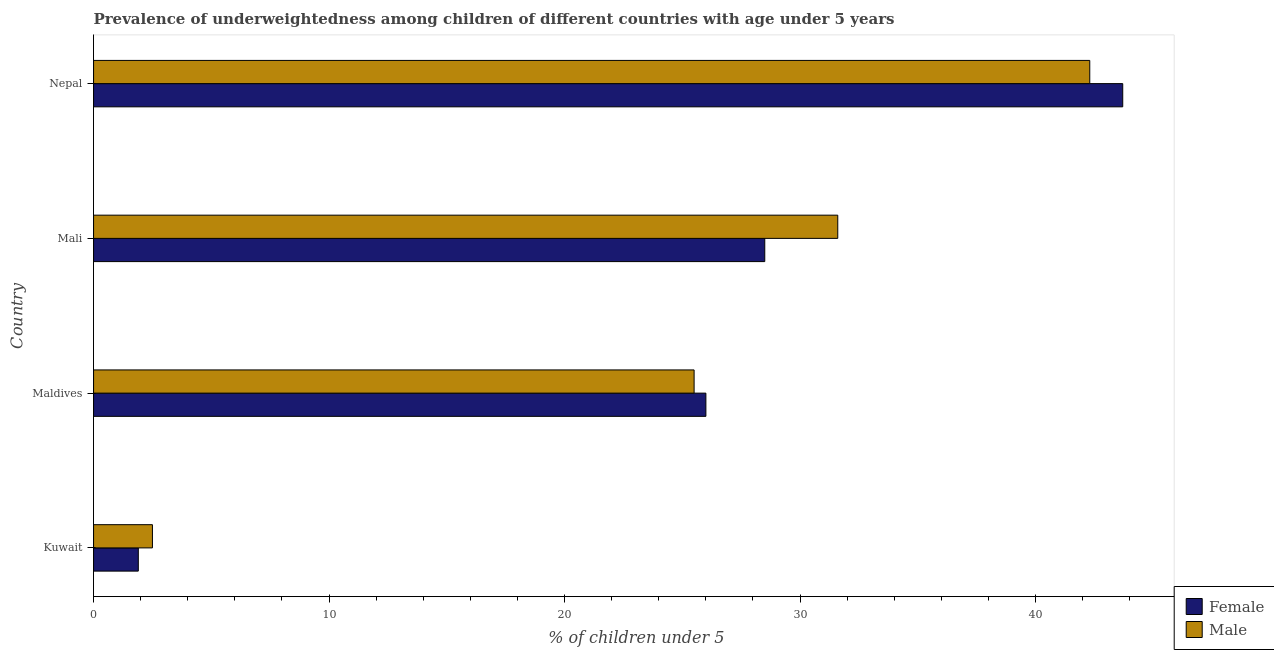How many different coloured bars are there?
Provide a short and direct response. 2. What is the label of the 4th group of bars from the top?
Your answer should be compact. Kuwait. Across all countries, what is the maximum percentage of underweighted female children?
Your response must be concise. 43.7. Across all countries, what is the minimum percentage of underweighted male children?
Offer a terse response. 2.5. In which country was the percentage of underweighted female children maximum?
Your answer should be very brief. Nepal. In which country was the percentage of underweighted female children minimum?
Give a very brief answer. Kuwait. What is the total percentage of underweighted female children in the graph?
Make the answer very short. 100.1. What is the difference between the percentage of underweighted male children in Maldives and that in Mali?
Make the answer very short. -6.1. What is the difference between the percentage of underweighted male children in Kuwait and the percentage of underweighted female children in Maldives?
Your answer should be very brief. -23.5. What is the average percentage of underweighted male children per country?
Your answer should be compact. 25.48. In how many countries, is the percentage of underweighted male children greater than 18 %?
Your answer should be compact. 3. What is the ratio of the percentage of underweighted female children in Kuwait to that in Maldives?
Provide a short and direct response. 0.07. Is the percentage of underweighted female children in Kuwait less than that in Nepal?
Your answer should be very brief. Yes. What is the difference between the highest and the lowest percentage of underweighted female children?
Provide a succinct answer. 41.8. In how many countries, is the percentage of underweighted female children greater than the average percentage of underweighted female children taken over all countries?
Offer a very short reply. 3. Is the sum of the percentage of underweighted female children in Maldives and Mali greater than the maximum percentage of underweighted male children across all countries?
Make the answer very short. Yes. How many bars are there?
Provide a succinct answer. 8. Does the graph contain grids?
Your answer should be very brief. No. Where does the legend appear in the graph?
Offer a very short reply. Bottom right. How many legend labels are there?
Give a very brief answer. 2. What is the title of the graph?
Your response must be concise. Prevalence of underweightedness among children of different countries with age under 5 years. Does "Methane emissions" appear as one of the legend labels in the graph?
Give a very brief answer. No. What is the label or title of the X-axis?
Keep it short and to the point.  % of children under 5. What is the  % of children under 5 of Female in Kuwait?
Your answer should be compact. 1.9. What is the  % of children under 5 in Male in Kuwait?
Provide a short and direct response. 2.5. What is the  % of children under 5 of Female in Mali?
Provide a short and direct response. 28.5. What is the  % of children under 5 of Male in Mali?
Your answer should be compact. 31.6. What is the  % of children under 5 in Female in Nepal?
Provide a short and direct response. 43.7. What is the  % of children under 5 of Male in Nepal?
Offer a very short reply. 42.3. Across all countries, what is the maximum  % of children under 5 in Female?
Keep it short and to the point. 43.7. Across all countries, what is the maximum  % of children under 5 in Male?
Your response must be concise. 42.3. Across all countries, what is the minimum  % of children under 5 of Female?
Ensure brevity in your answer.  1.9. Across all countries, what is the minimum  % of children under 5 in Male?
Ensure brevity in your answer.  2.5. What is the total  % of children under 5 in Female in the graph?
Offer a very short reply. 100.1. What is the total  % of children under 5 of Male in the graph?
Keep it short and to the point. 101.9. What is the difference between the  % of children under 5 of Female in Kuwait and that in Maldives?
Make the answer very short. -24.1. What is the difference between the  % of children under 5 in Female in Kuwait and that in Mali?
Your answer should be compact. -26.6. What is the difference between the  % of children under 5 in Male in Kuwait and that in Mali?
Give a very brief answer. -29.1. What is the difference between the  % of children under 5 in Female in Kuwait and that in Nepal?
Offer a terse response. -41.8. What is the difference between the  % of children under 5 in Male in Kuwait and that in Nepal?
Provide a short and direct response. -39.8. What is the difference between the  % of children under 5 in Female in Maldives and that in Nepal?
Offer a terse response. -17.7. What is the difference between the  % of children under 5 of Male in Maldives and that in Nepal?
Offer a very short reply. -16.8. What is the difference between the  % of children under 5 in Female in Mali and that in Nepal?
Ensure brevity in your answer.  -15.2. What is the difference between the  % of children under 5 in Female in Kuwait and the  % of children under 5 in Male in Maldives?
Give a very brief answer. -23.6. What is the difference between the  % of children under 5 of Female in Kuwait and the  % of children under 5 of Male in Mali?
Offer a terse response. -29.7. What is the difference between the  % of children under 5 of Female in Kuwait and the  % of children under 5 of Male in Nepal?
Give a very brief answer. -40.4. What is the difference between the  % of children under 5 of Female in Maldives and the  % of children under 5 of Male in Nepal?
Give a very brief answer. -16.3. What is the difference between the  % of children under 5 in Female in Mali and the  % of children under 5 in Male in Nepal?
Keep it short and to the point. -13.8. What is the average  % of children under 5 in Female per country?
Give a very brief answer. 25.02. What is the average  % of children under 5 of Male per country?
Your response must be concise. 25.48. What is the difference between the  % of children under 5 of Female and  % of children under 5 of Male in Maldives?
Offer a very short reply. 0.5. What is the ratio of the  % of children under 5 of Female in Kuwait to that in Maldives?
Give a very brief answer. 0.07. What is the ratio of the  % of children under 5 in Male in Kuwait to that in Maldives?
Keep it short and to the point. 0.1. What is the ratio of the  % of children under 5 in Female in Kuwait to that in Mali?
Give a very brief answer. 0.07. What is the ratio of the  % of children under 5 in Male in Kuwait to that in Mali?
Provide a short and direct response. 0.08. What is the ratio of the  % of children under 5 in Female in Kuwait to that in Nepal?
Provide a succinct answer. 0.04. What is the ratio of the  % of children under 5 of Male in Kuwait to that in Nepal?
Offer a very short reply. 0.06. What is the ratio of the  % of children under 5 in Female in Maldives to that in Mali?
Give a very brief answer. 0.91. What is the ratio of the  % of children under 5 of Male in Maldives to that in Mali?
Your answer should be very brief. 0.81. What is the ratio of the  % of children under 5 of Female in Maldives to that in Nepal?
Your answer should be compact. 0.59. What is the ratio of the  % of children under 5 in Male in Maldives to that in Nepal?
Your response must be concise. 0.6. What is the ratio of the  % of children under 5 of Female in Mali to that in Nepal?
Give a very brief answer. 0.65. What is the ratio of the  % of children under 5 in Male in Mali to that in Nepal?
Provide a short and direct response. 0.75. What is the difference between the highest and the second highest  % of children under 5 in Female?
Ensure brevity in your answer.  15.2. What is the difference between the highest and the second highest  % of children under 5 in Male?
Give a very brief answer. 10.7. What is the difference between the highest and the lowest  % of children under 5 of Female?
Ensure brevity in your answer.  41.8. What is the difference between the highest and the lowest  % of children under 5 of Male?
Make the answer very short. 39.8. 